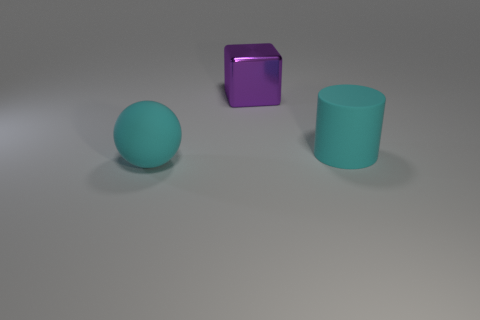There is a sphere that is the same material as the cyan cylinder; what is its color?
Your response must be concise. Cyan. Are there the same number of metal cubes that are left of the cyan sphere and large cyan objects?
Offer a very short reply. No. There is a rubber object that is the same size as the matte cylinder; what is its shape?
Your response must be concise. Sphere. What number of other objects are there of the same shape as the big shiny thing?
Make the answer very short. 0. There is a cylinder; is its size the same as the block that is behind the cyan rubber sphere?
Ensure brevity in your answer.  Yes. What number of objects are either large cyan matte objects that are on the left side of the purple cube or rubber spheres?
Offer a terse response. 1. The cyan thing that is right of the cyan ball has what shape?
Give a very brief answer. Cylinder. Is the number of objects that are on the left side of the cyan sphere the same as the number of cyan cylinders behind the block?
Offer a terse response. Yes. There is a thing that is behind the big ball and left of the rubber cylinder; what color is it?
Provide a short and direct response. Purple. The large cube that is behind the cyan matte object in front of the matte cylinder is made of what material?
Your response must be concise. Metal. 